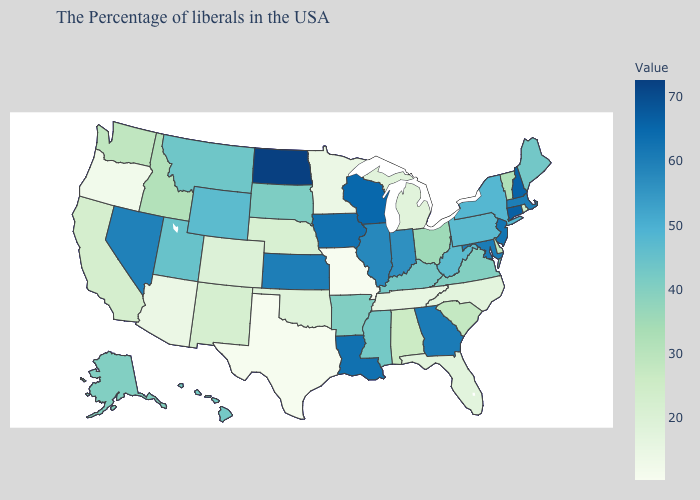Does Maine have the lowest value in the Northeast?
Keep it brief. No. Among the states that border North Dakota , which have the lowest value?
Answer briefly. Minnesota. Among the states that border New Mexico , which have the lowest value?
Quick response, please. Texas. Which states have the lowest value in the USA?
Be succinct. Missouri. Does the map have missing data?
Keep it brief. No. Does North Dakota have the lowest value in the USA?
Be succinct. No. Does Florida have the highest value in the USA?
Write a very short answer. No. Does Michigan have a lower value than Missouri?
Keep it brief. No. 